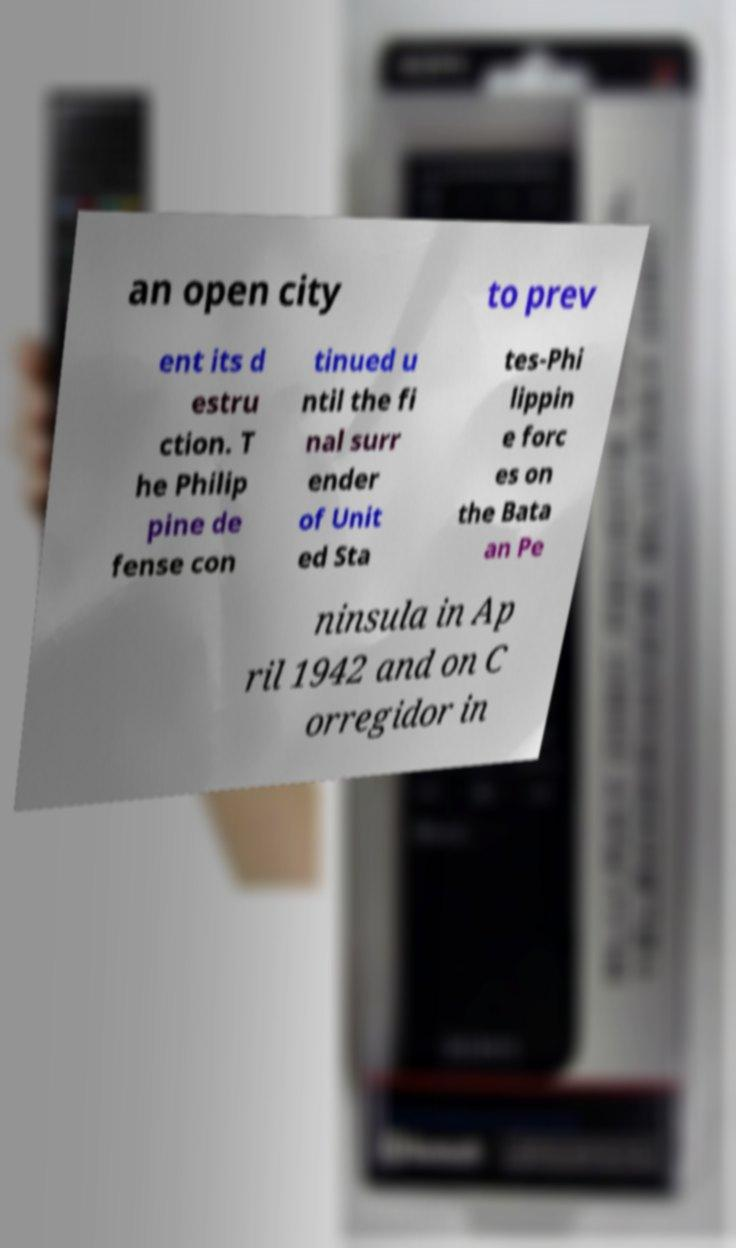I need the written content from this picture converted into text. Can you do that? an open city to prev ent its d estru ction. T he Philip pine de fense con tinued u ntil the fi nal surr ender of Unit ed Sta tes-Phi lippin e forc es on the Bata an Pe ninsula in Ap ril 1942 and on C orregidor in 